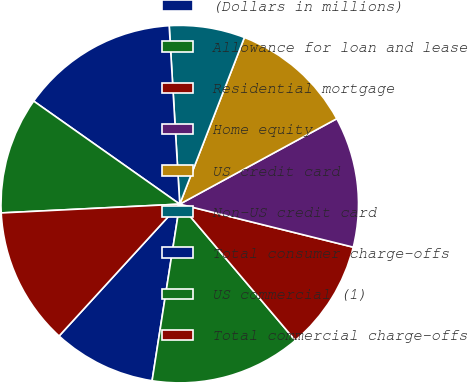<chart> <loc_0><loc_0><loc_500><loc_500><pie_chart><fcel>(Dollars in millions)<fcel>Allowance for loan and lease<fcel>Residential mortgage<fcel>Home equity<fcel>US credit card<fcel>Non-US credit card<fcel>Total consumer charge-offs<fcel>US commercial (1)<fcel>Total commercial charge-offs<nl><fcel>9.32%<fcel>13.66%<fcel>9.94%<fcel>11.8%<fcel>11.18%<fcel>6.83%<fcel>14.28%<fcel>10.56%<fcel>12.42%<nl></chart> 